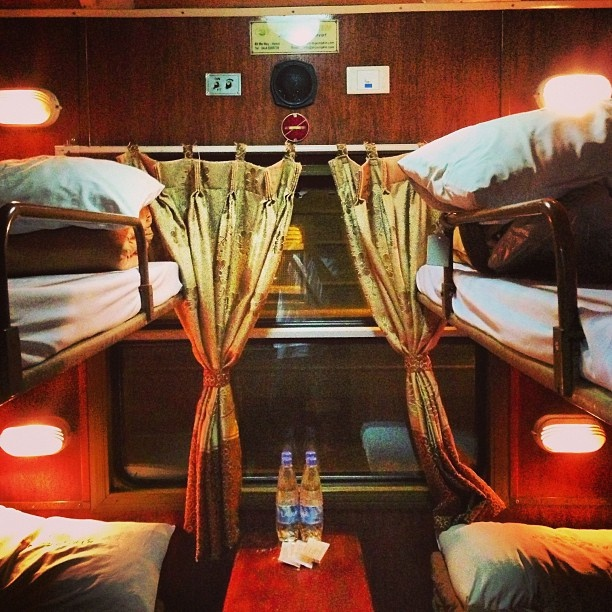Describe the objects in this image and their specific colors. I can see bed in maroon, black, lightgray, and darkgray tones, bed in maroon, black, darkgray, and lightgray tones, bed in maroon, black, lightgray, gray, and tan tones, bed in maroon, black, tan, and red tones, and bottle in maroon, brown, salmon, gray, and tan tones in this image. 